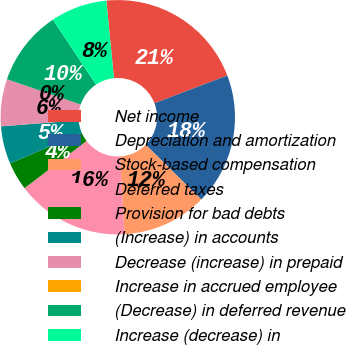<chart> <loc_0><loc_0><loc_500><loc_500><pie_chart><fcel>Net income<fcel>Depreciation and amortization<fcel>Stock-based compensation<fcel>Deferred taxes<fcel>Provision for bad debts<fcel>(Increase) in accounts<fcel>Decrease (increase) in prepaid<fcel>Increase in accrued employee<fcel>(Decrease) in deferred revenue<fcel>Increase (decrease) in<nl><fcel>20.77%<fcel>18.18%<fcel>11.69%<fcel>15.58%<fcel>3.9%<fcel>5.2%<fcel>6.5%<fcel>0.0%<fcel>10.39%<fcel>7.79%<nl></chart> 